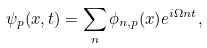Convert formula to latex. <formula><loc_0><loc_0><loc_500><loc_500>\psi _ { p } ( x , t ) = \sum _ { n } \phi _ { n , p } ( x ) e ^ { i \Omega n t } ,</formula> 